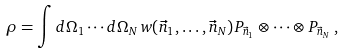<formula> <loc_0><loc_0><loc_500><loc_500>\rho = \int d \Omega _ { 1 } \cdots d \Omega _ { N } \, w ( { \vec { n } } _ { 1 } , \dots , { \vec { n } } _ { N } ) P _ { { \vec { n } } _ { 1 } } \otimes \cdots \otimes P _ { { \vec { n } } _ { N } } \, ,</formula> 